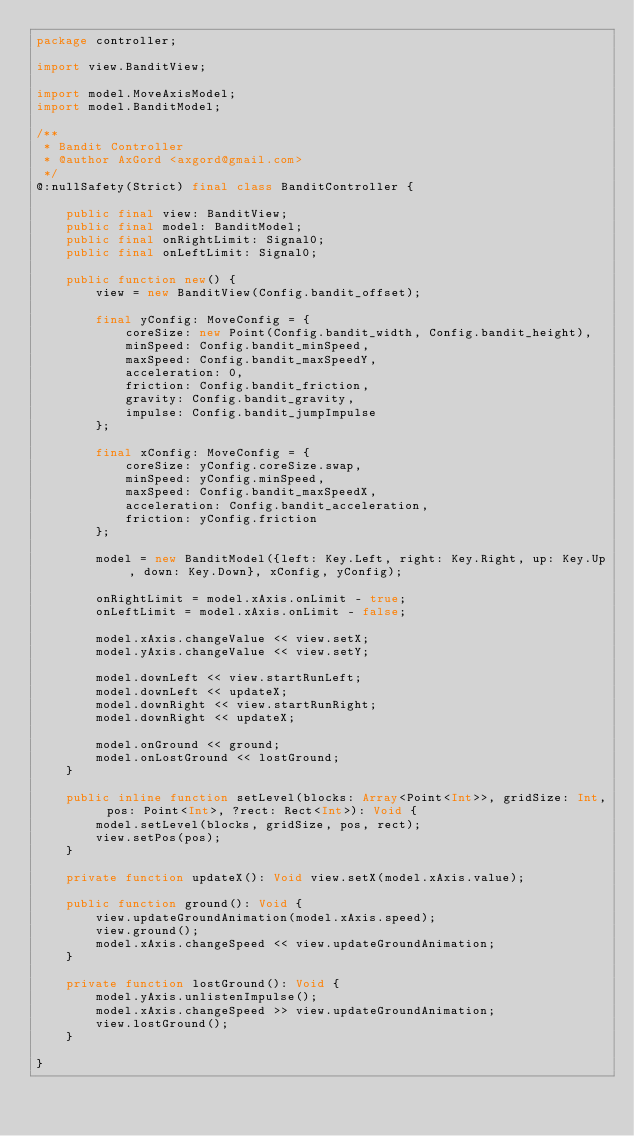Convert code to text. <code><loc_0><loc_0><loc_500><loc_500><_Haxe_>package controller;

import view.BanditView;

import model.MoveAxisModel;
import model.BanditModel;

/**
 * Bandit Controller
 * @author AxGord <axgord@gmail.com>
 */
@:nullSafety(Strict) final class BanditController {

	public final view: BanditView;
	public final model: BanditModel;
	public final onRightLimit: Signal0;
	public final onLeftLimit: Signal0;

	public function new() {
		view = new BanditView(Config.bandit_offset);

		final yConfig: MoveConfig = {
			coreSize: new Point(Config.bandit_width, Config.bandit_height),
			minSpeed: Config.bandit_minSpeed,
			maxSpeed: Config.bandit_maxSpeedY,
			acceleration: 0,
			friction: Config.bandit_friction,
			gravity: Config.bandit_gravity,
			impulse: Config.bandit_jumpImpulse
		};

		final xConfig: MoveConfig = {
			coreSize: yConfig.coreSize.swap,
			minSpeed: yConfig.minSpeed,
			maxSpeed: Config.bandit_maxSpeedX,
			acceleration: Config.bandit_acceleration,
			friction: yConfig.friction
		};

		model = new BanditModel({left: Key.Left, right: Key.Right, up: Key.Up, down: Key.Down}, xConfig, yConfig);

		onRightLimit = model.xAxis.onLimit - true;
		onLeftLimit = model.xAxis.onLimit - false;

		model.xAxis.changeValue << view.setX;
		model.yAxis.changeValue << view.setY;

		model.downLeft << view.startRunLeft;
		model.downLeft << updateX;
		model.downRight << view.startRunRight;
		model.downRight << updateX;

		model.onGround << ground;
		model.onLostGround << lostGround;
	}

	public inline function setLevel(blocks: Array<Point<Int>>, gridSize: Int, pos: Point<Int>, ?rect: Rect<Int>): Void {
		model.setLevel(blocks, gridSize, pos, rect);
		view.setPos(pos);
	}

	private function updateX(): Void view.setX(model.xAxis.value);

	public function ground(): Void {
		view.updateGroundAnimation(model.xAxis.speed);
		view.ground();
		model.xAxis.changeSpeed << view.updateGroundAnimation;
	}

	private function lostGround(): Void {
		model.yAxis.unlistenImpulse();
		model.xAxis.changeSpeed >> view.updateGroundAnimation;
		view.lostGround();
	}

}</code> 